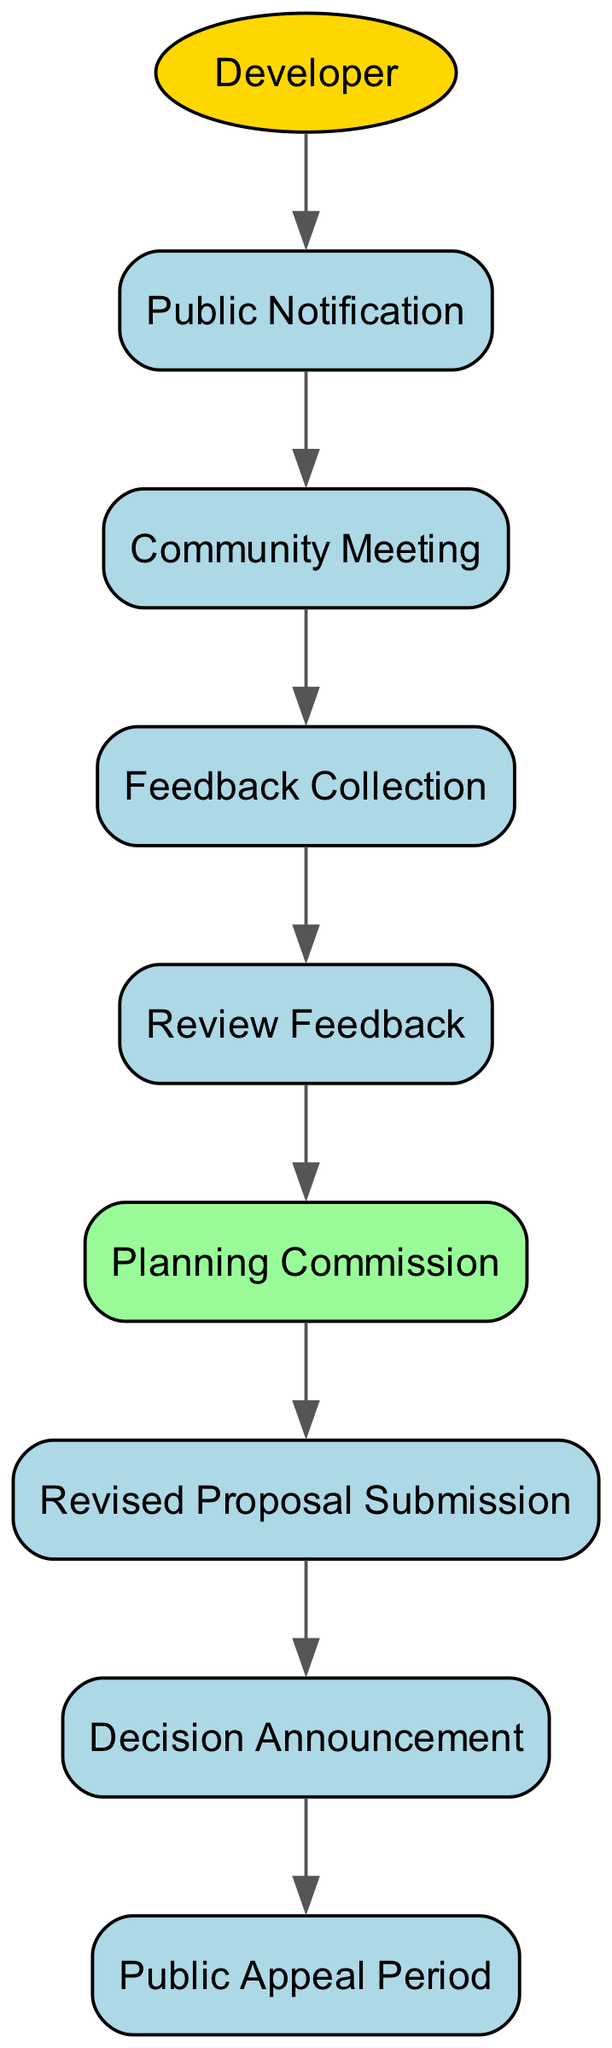What is the first event in the public consultation process? The diagram starts with the "Public Notification" event which follows the Developer's action. It indicates the beginning of the public consultation process.
Answer: Public Notification How many events are included in this consultation process? By counting the events listed in the diagram, there are a total of seven events starting from "Public Notification" to "Public Appeal Period."
Answer: Seven Which actor initiates the consultation process? The diagram shows that the "Developer" is the actor that starts the sequence by sending out the "Public Notification."
Answer: Developer What happens immediately after the "Community Meeting"? The sequence indicates that after the "Community Meeting," the next step is "Feedback Collection," demonstrating that feedback is gathered post-meeting.
Answer: Feedback Collection Which entity reviews the feedback collected from the public? According to the flow in the diagram, the "Planning Commission" is responsible for reviewing the feedback collected after the public meeting.
Answer: Planning Commission How many steps are there from "Review Feedback" to "Decision Announcement"? The steps from "Review Feedback" to "Decision Announcement" consist of two actions: the "Revised Proposal Submission" and the "Decision Announcement," showing they are sequentially linked.
Answer: Two What is the final event in the public consultation process? Looking at the end of the sequence, the last event that concludes the public consultation process is the "Public Appeal Period," where further public engagement may occur.
Answer: Public Appeal Period What is the relationship between "Revised Proposal Submission" and "Planning Commission"? The diagram illustrates a direct relationship where the "Planning Commission" reviews the feedback and subsequently leads to the "Revised Proposal Submission" event.
Answer: Sequential What stage follows the "Decision Announcement"? The diagram clearly indicates that following the "Decision Announcement," the process leads to the "Public Appeal Period," allowing for any public objections or appeals to be made.
Answer: Public Appeal Period 